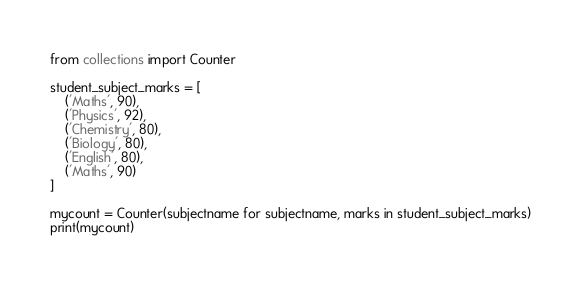<code> <loc_0><loc_0><loc_500><loc_500><_Python_>from collections import Counter

student_subject_marks = [
    ('Maths', 90),
    ('Physics', 92),
    ('Chemistry', 80),
    ('Biology', 80),
    ('English', 80),
    ('Maths', 90)
]

mycount = Counter(subjectname for subjectname, marks in student_subject_marks)
print(mycount)
</code> 